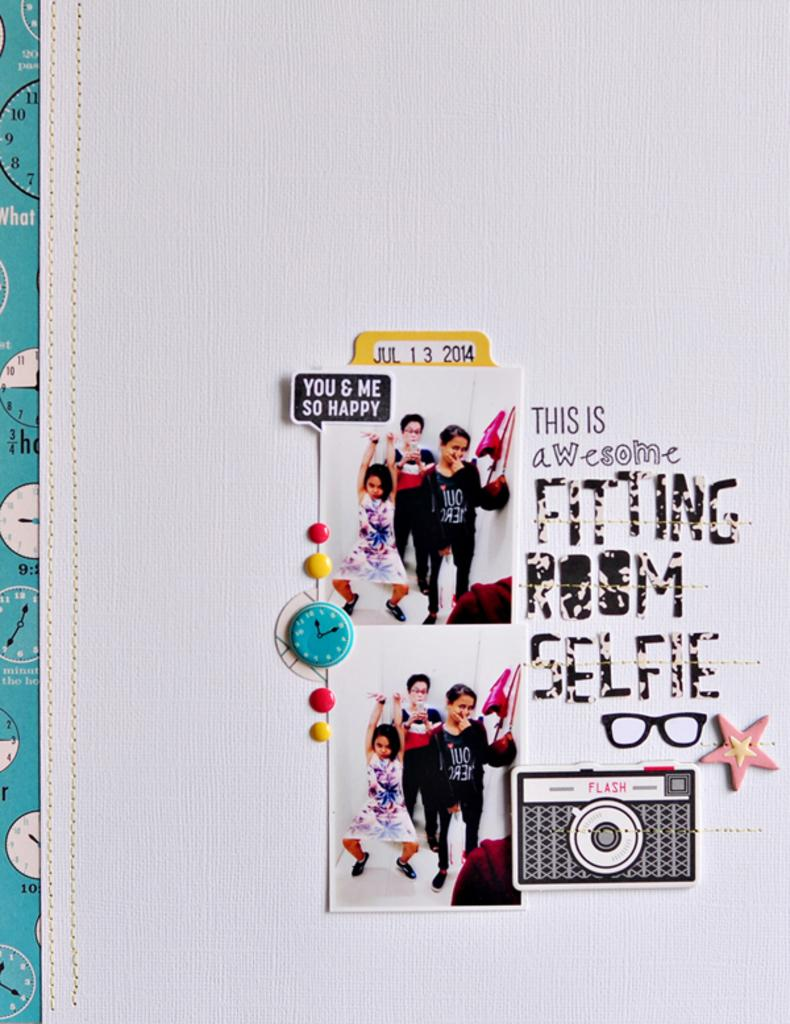<image>
Present a compact description of the photo's key features. the year 2014 is on a paper item 